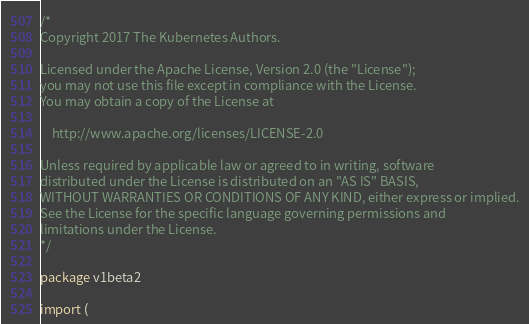Convert code to text. <code><loc_0><loc_0><loc_500><loc_500><_Go_>/*
Copyright 2017 The Kubernetes Authors.

Licensed under the Apache License, Version 2.0 (the "License");
you may not use this file except in compliance with the License.
You may obtain a copy of the License at

    http://www.apache.org/licenses/LICENSE-2.0

Unless required by applicable law or agreed to in writing, software
distributed under the License is distributed on an "AS IS" BASIS,
WITHOUT WARRANTIES OR CONDITIONS OF ANY KIND, either express or implied.
See the License for the specific language governing permissions and
limitations under the License.
*/

package v1beta2

import (</code> 